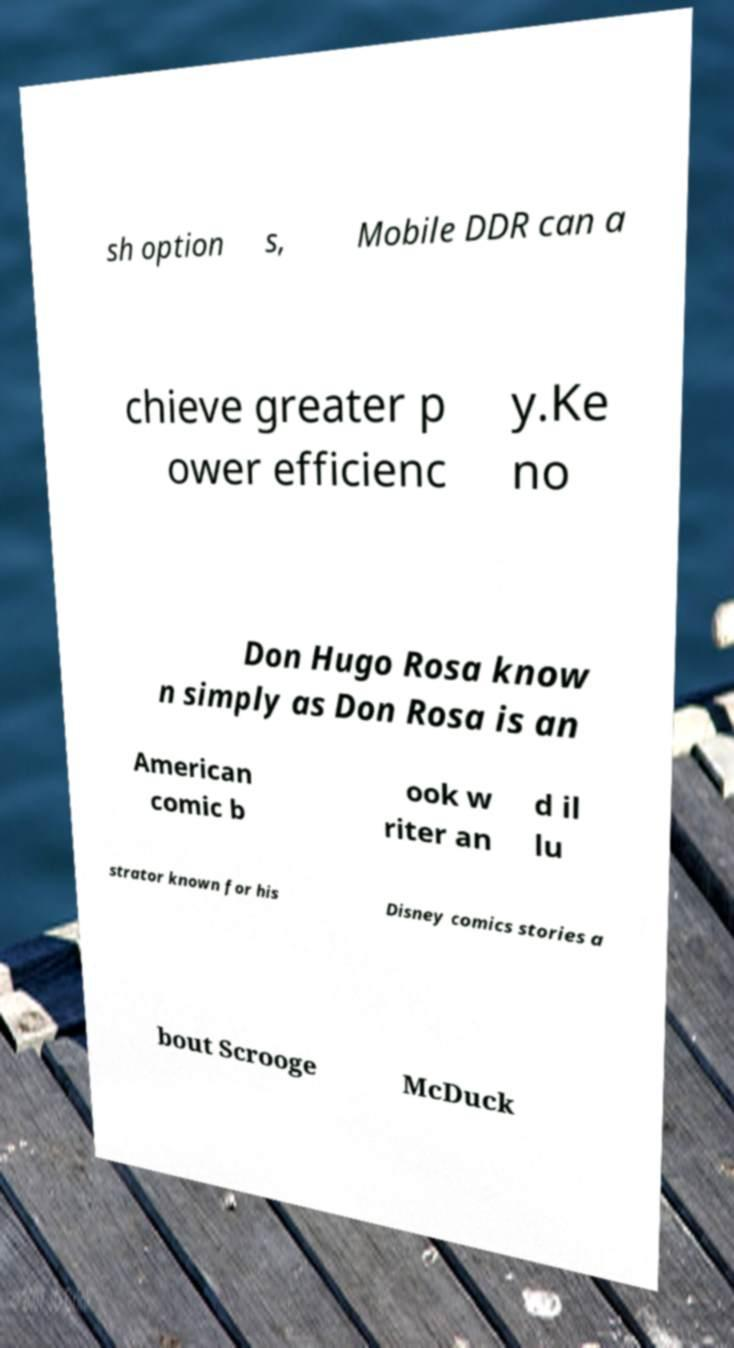Please read and relay the text visible in this image. What does it say? sh option s, Mobile DDR can a chieve greater p ower efficienc y.Ke no Don Hugo Rosa know n simply as Don Rosa is an American comic b ook w riter an d il lu strator known for his Disney comics stories a bout Scrooge McDuck 